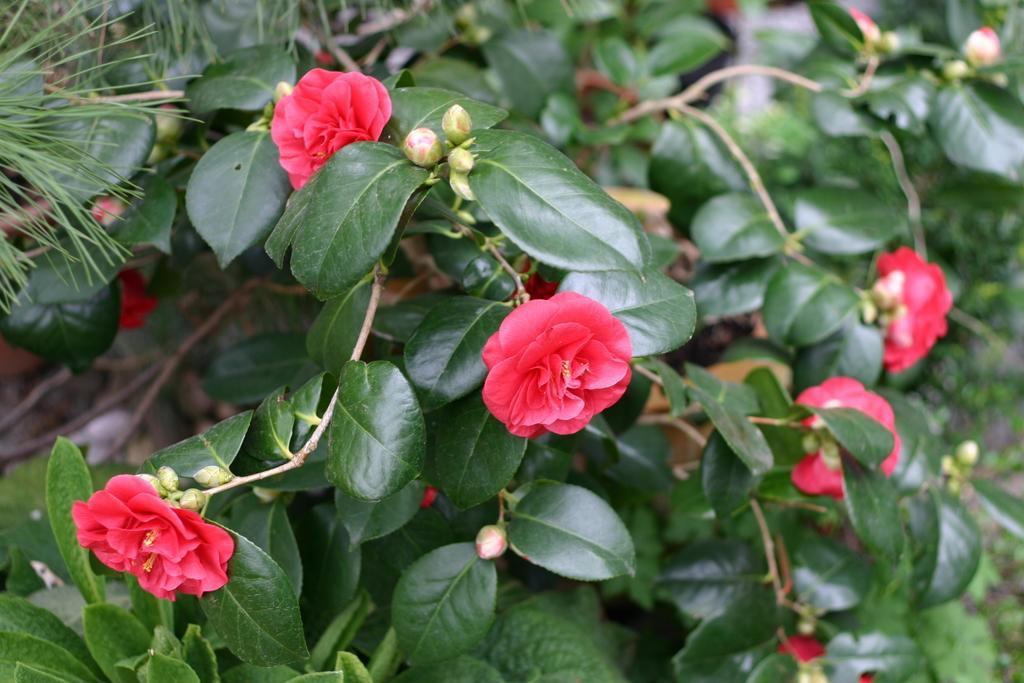How would you summarize this image in a sentence or two? This picture shows few plants with flowers and we see pots and flowers are red in color. 